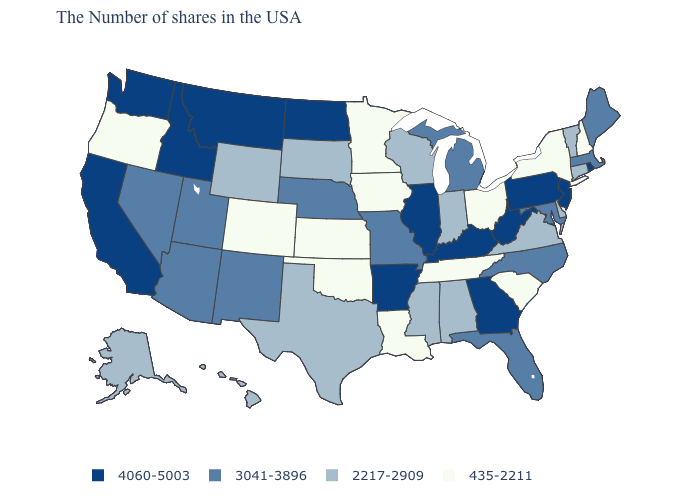Does the map have missing data?
Answer briefly. No. Does Louisiana have the lowest value in the USA?
Concise answer only. Yes. What is the value of Maine?
Quick response, please. 3041-3896. Does South Carolina have the lowest value in the USA?
Short answer required. Yes. Which states have the lowest value in the USA?
Keep it brief. New Hampshire, New York, South Carolina, Ohio, Tennessee, Louisiana, Minnesota, Iowa, Kansas, Oklahoma, Colorado, Oregon. Name the states that have a value in the range 3041-3896?
Quick response, please. Maine, Massachusetts, Maryland, North Carolina, Florida, Michigan, Missouri, Nebraska, New Mexico, Utah, Arizona, Nevada. Does the first symbol in the legend represent the smallest category?
Be succinct. No. Which states hav the highest value in the West?
Short answer required. Montana, Idaho, California, Washington. Does Missouri have the highest value in the MidWest?
Write a very short answer. No. Name the states that have a value in the range 4060-5003?
Short answer required. Rhode Island, New Jersey, Pennsylvania, West Virginia, Georgia, Kentucky, Illinois, Arkansas, North Dakota, Montana, Idaho, California, Washington. Name the states that have a value in the range 3041-3896?
Keep it brief. Maine, Massachusetts, Maryland, North Carolina, Florida, Michigan, Missouri, Nebraska, New Mexico, Utah, Arizona, Nevada. What is the lowest value in the USA?
Keep it brief. 435-2211. Name the states that have a value in the range 3041-3896?
Concise answer only. Maine, Massachusetts, Maryland, North Carolina, Florida, Michigan, Missouri, Nebraska, New Mexico, Utah, Arizona, Nevada. What is the value of South Carolina?
Be succinct. 435-2211. Among the states that border New York , does Pennsylvania have the highest value?
Write a very short answer. Yes. 